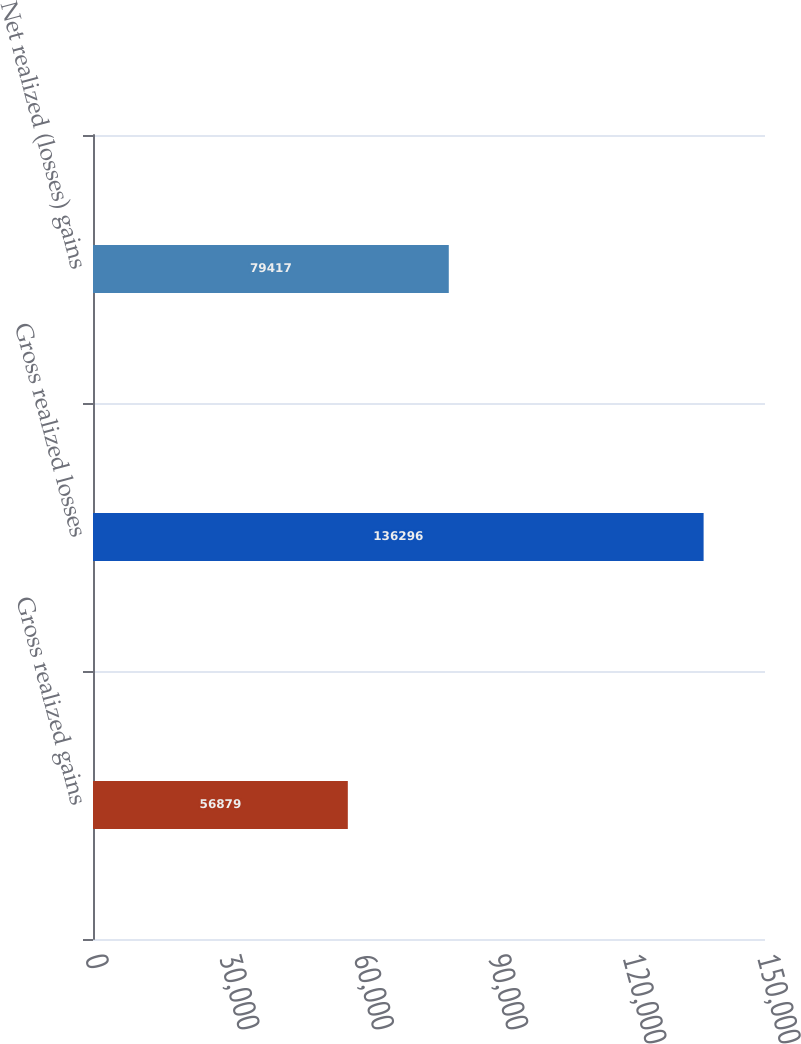<chart> <loc_0><loc_0><loc_500><loc_500><bar_chart><fcel>Gross realized gains<fcel>Gross realized losses<fcel>Net realized (losses) gains<nl><fcel>56879<fcel>136296<fcel>79417<nl></chart> 